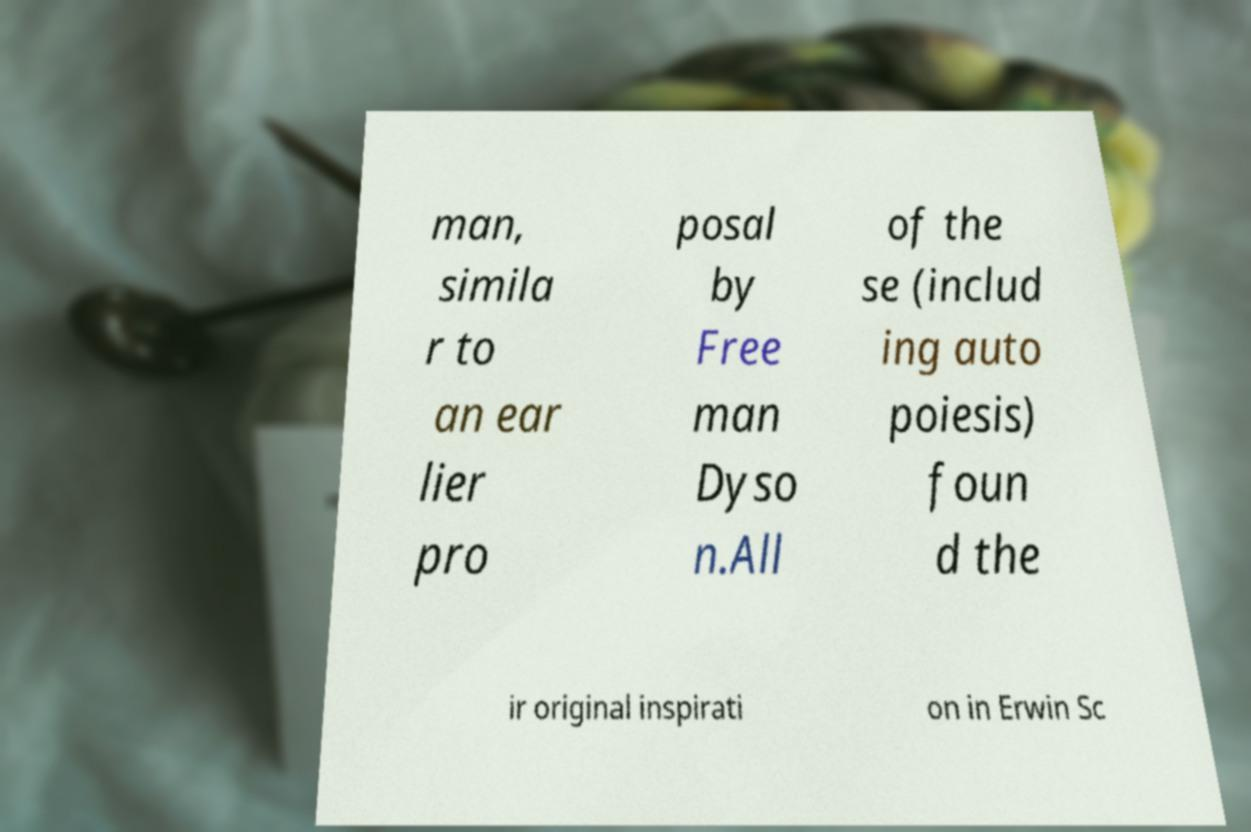Could you assist in decoding the text presented in this image and type it out clearly? man, simila r to an ear lier pro posal by Free man Dyso n.All of the se (includ ing auto poiesis) foun d the ir original inspirati on in Erwin Sc 